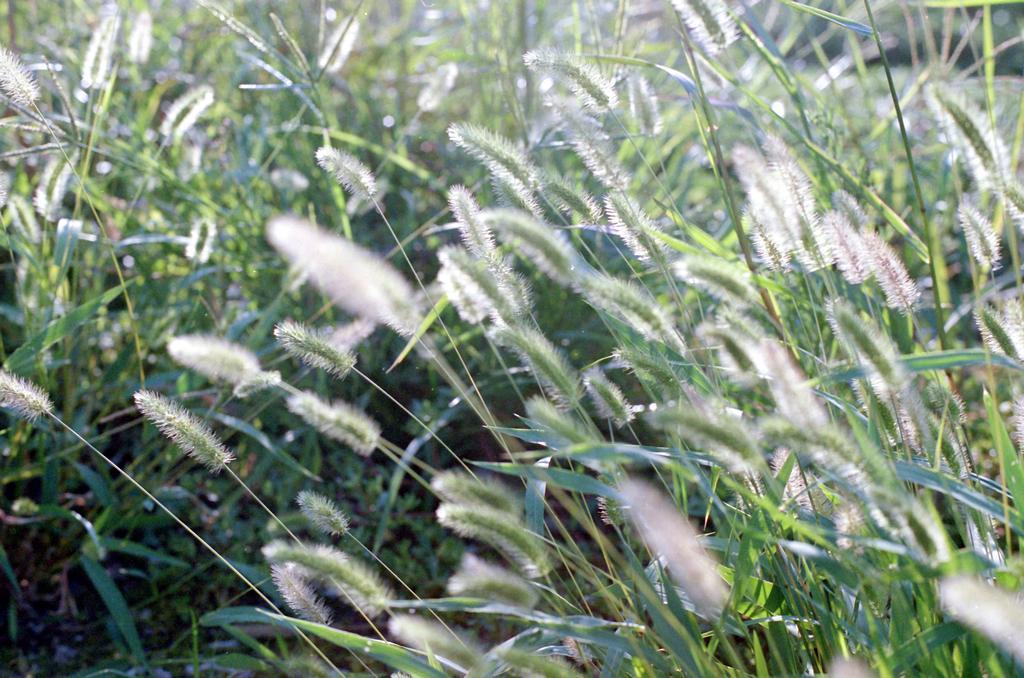Describe this image in one or two sentences. In this picture I can see number of plants and I see white and green color things on it. 